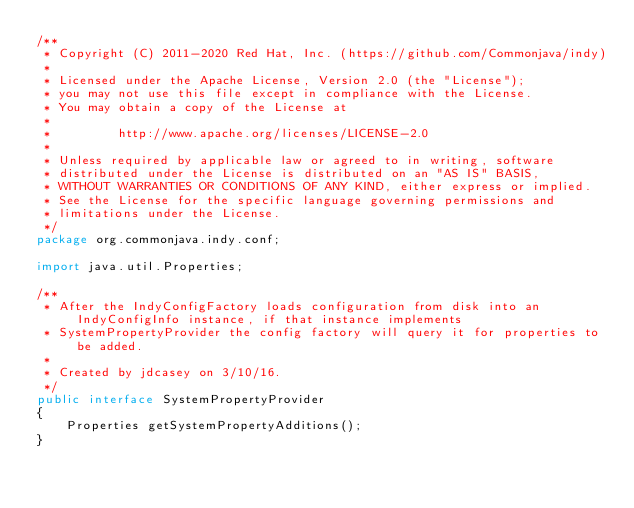<code> <loc_0><loc_0><loc_500><loc_500><_Java_>/**
 * Copyright (C) 2011-2020 Red Hat, Inc. (https://github.com/Commonjava/indy)
 *
 * Licensed under the Apache License, Version 2.0 (the "License");
 * you may not use this file except in compliance with the License.
 * You may obtain a copy of the License at
 *
 *         http://www.apache.org/licenses/LICENSE-2.0
 *
 * Unless required by applicable law or agreed to in writing, software
 * distributed under the License is distributed on an "AS IS" BASIS,
 * WITHOUT WARRANTIES OR CONDITIONS OF ANY KIND, either express or implied.
 * See the License for the specific language governing permissions and
 * limitations under the License.
 */
package org.commonjava.indy.conf;

import java.util.Properties;

/**
 * After the IndyConfigFactory loads configuration from disk into an IndyConfigInfo instance, if that instance implements
 * SystemPropertyProvider the config factory will query it for properties to be added.
 *
 * Created by jdcasey on 3/10/16.
 */
public interface SystemPropertyProvider
{
    Properties getSystemPropertyAdditions();
}
</code> 